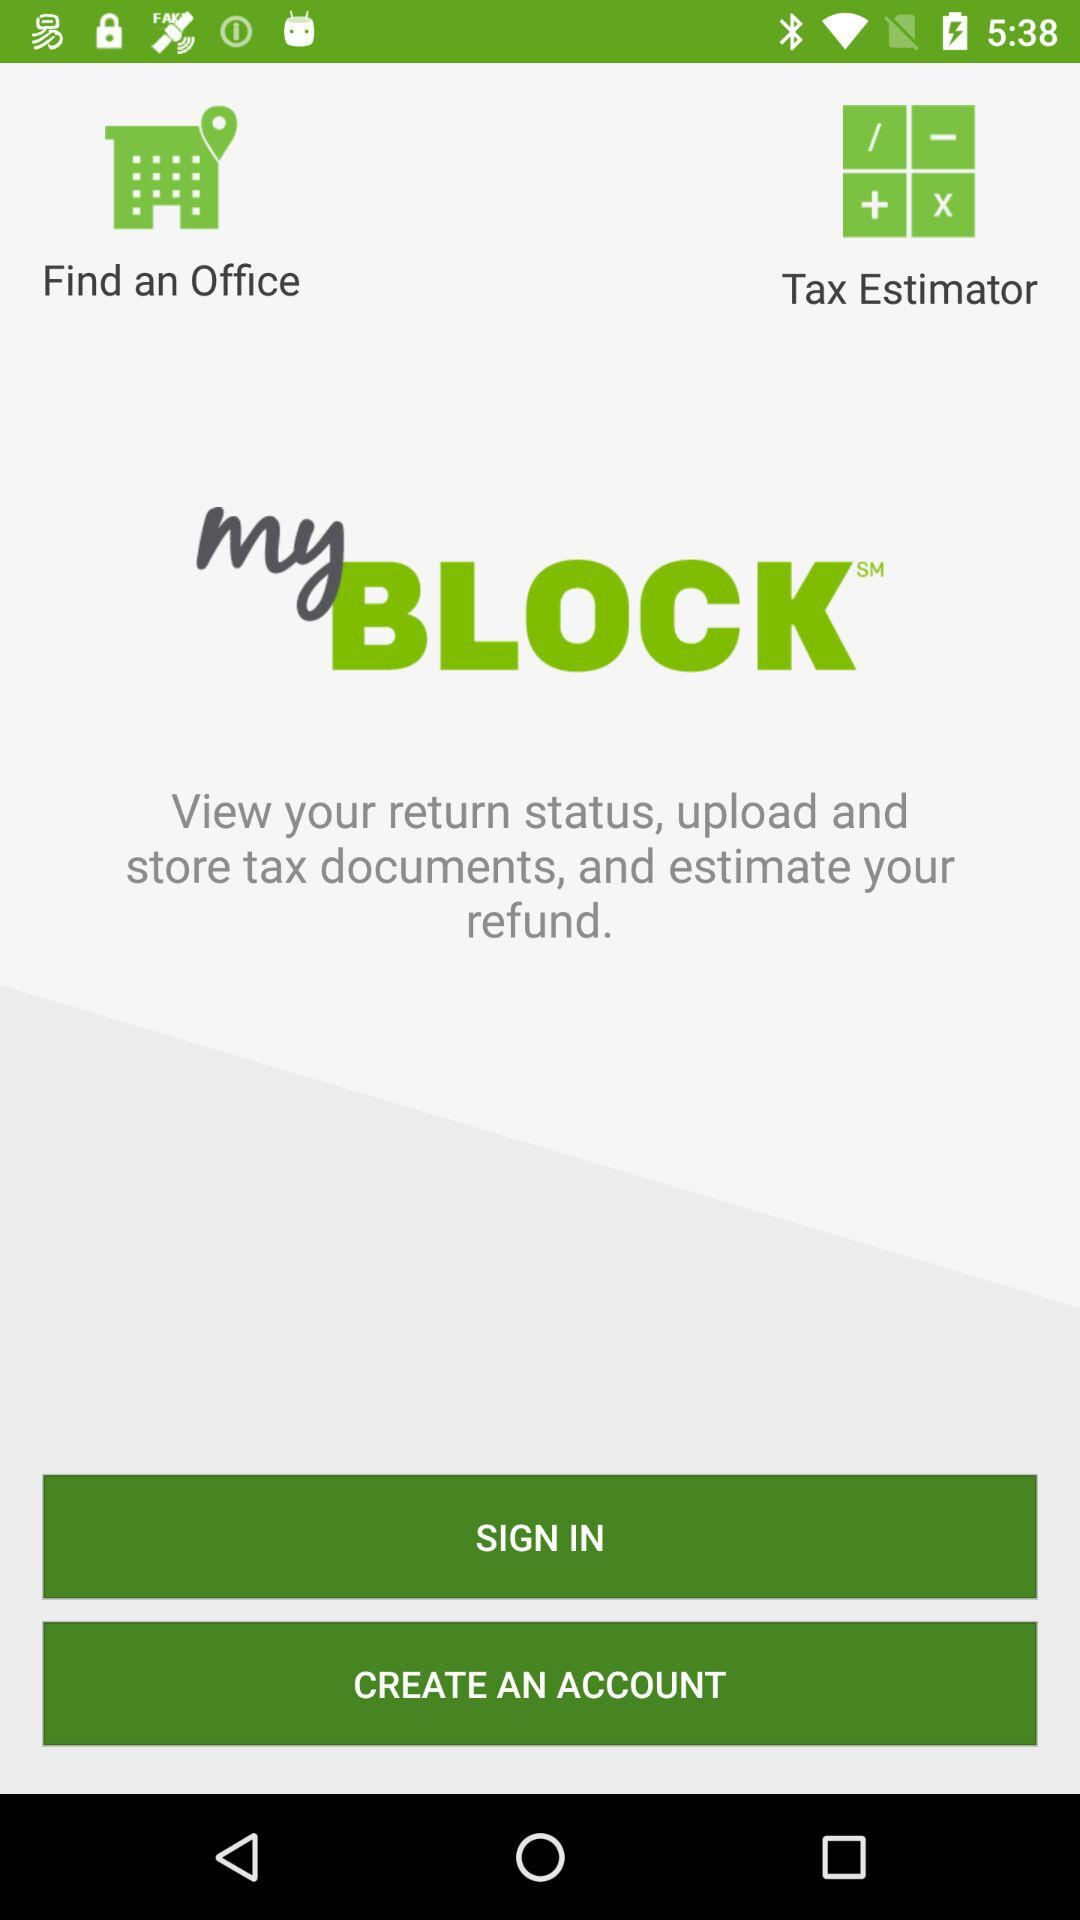What is the application name? The application name is "myBLOCK". 